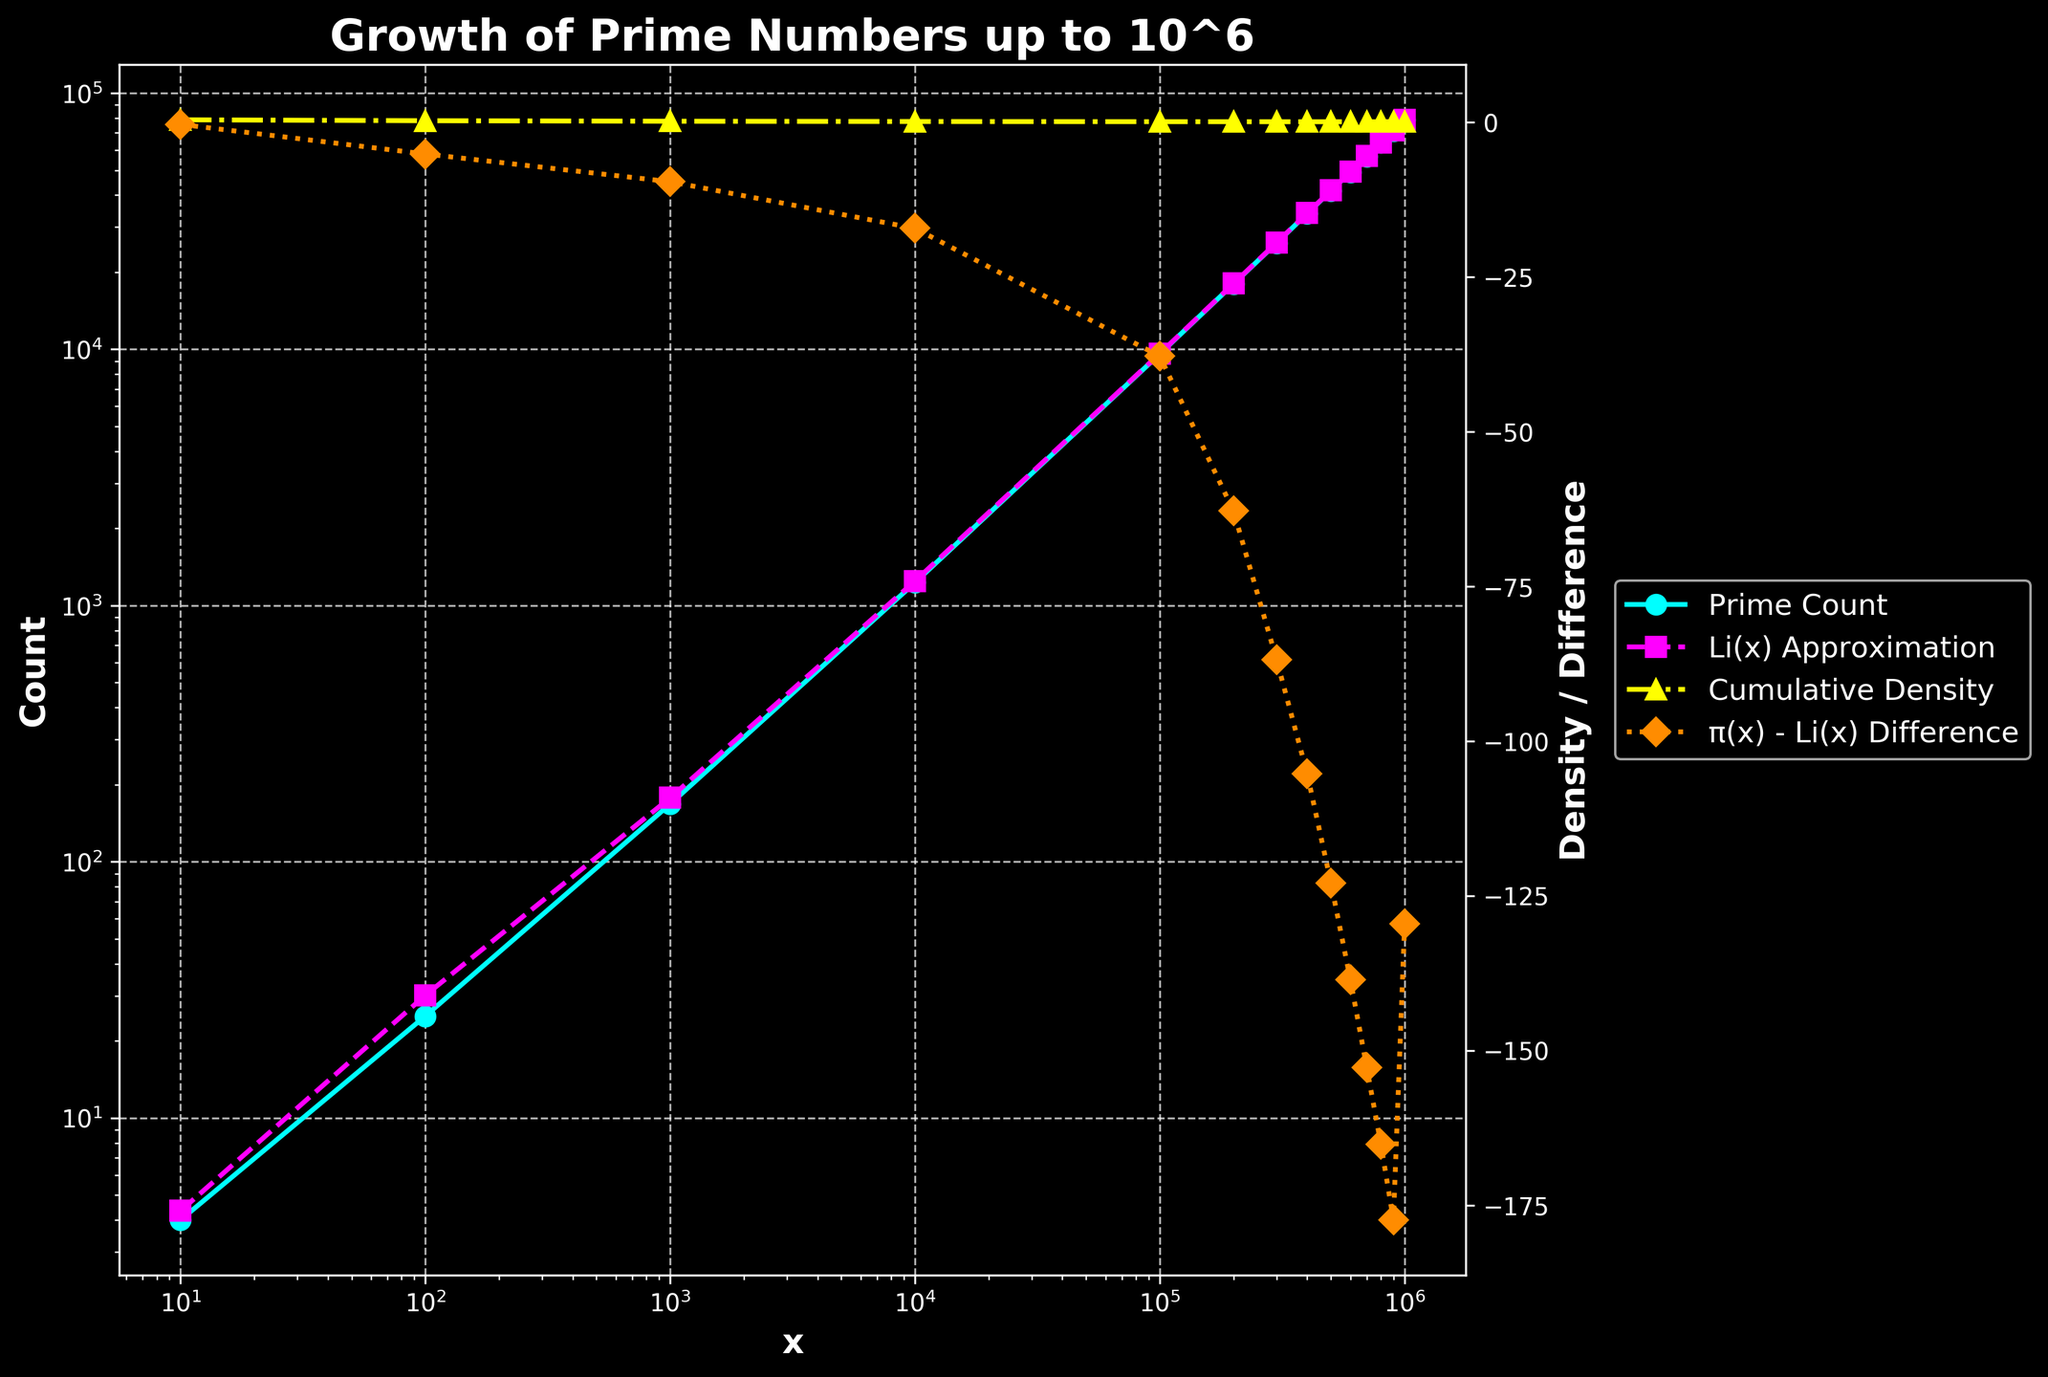Which curve represents the prime count data? The prime count data is represented by the line plotted with circular markers and a solid line. It is the data set labeled "Prime Count" in the legend and colored in cyan.
Answer: The cyan line with circular markers How does the Li(x) approximation compare to the prime count at x = 1000000? At x = 1000000, the Li(x) approximation is slightly higher than the prime count. The Li(x) approximation is around 78627.5491, while the actual prime count is 78498.
Answer: The Li(x) approximation is higher by approximately 129.5491 What is the general trend of the cumulative density as x increases from 10 to 1000000? The cumulative density decreases as x increases from 10 to 1000000. Initially, it is 0.4000 at x = 10 and gradually reduces to 0.0785 by x = 1000000.
Answer: It decreases At approximately which x-value does the "π(x) - Li(x) Difference" first drop below -100? The "π(x) - Li(x) Difference" drops below -100 around x = 400000. Before 400000, at x = 300000, the difference is -86.8614, and at x = 400000, it is -105.2822.
Answer: Around x = 400000 When comparing x = 10000 and x = 100000, how much larger is the prime count in the latter? The prime count at x = 100000 is 9592, and at x = 10000, it is 1229. The difference is 9592 - 1229 = 8363.
Answer: 8363 What does the yellow line in the plot represent, and what is its approximate value at x = 50000? The yellow line represents the cumulative density. At around x = 50000, its value is just slightly below 0.1, aligning closely with the cumulative density values of its adjacent points.
Answer: Slightly below 0.1 Describe the visual difference between the prime count and Li(x) approximation lines. The prime count line is a solid cyan line with circular markers, while the Li(x) approximation line is a dashed magenta line with square markers. The prime count line consistently stays below the Li(x) approximation line.
Answer: The prime count line is solid cyan; Li(x) approximation is dashed magenta Is there a point where the "π(x) - Li(x) Difference" line becomes less steep, and if so, approximately where? Yes, the difference becomes less steep showing a slower rate of decrease after x = 400000, where the line transitions from being sharply decreasing to less steep.
Answer: After x = 400000 Which y-axis (left or right) corresponds to the cumulative density of prime numbers? The cumulative density of prime numbers is shown on the right y-axis. This can be inferred from the yellow line representing the cumulative density, which aligns with the axis on the right.
Answer: The right y-axis 